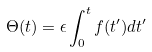Convert formula to latex. <formula><loc_0><loc_0><loc_500><loc_500>\Theta ( t ) = \epsilon \int ^ { t } _ { 0 } f ( t ^ { \prime } ) d t ^ { \prime }</formula> 